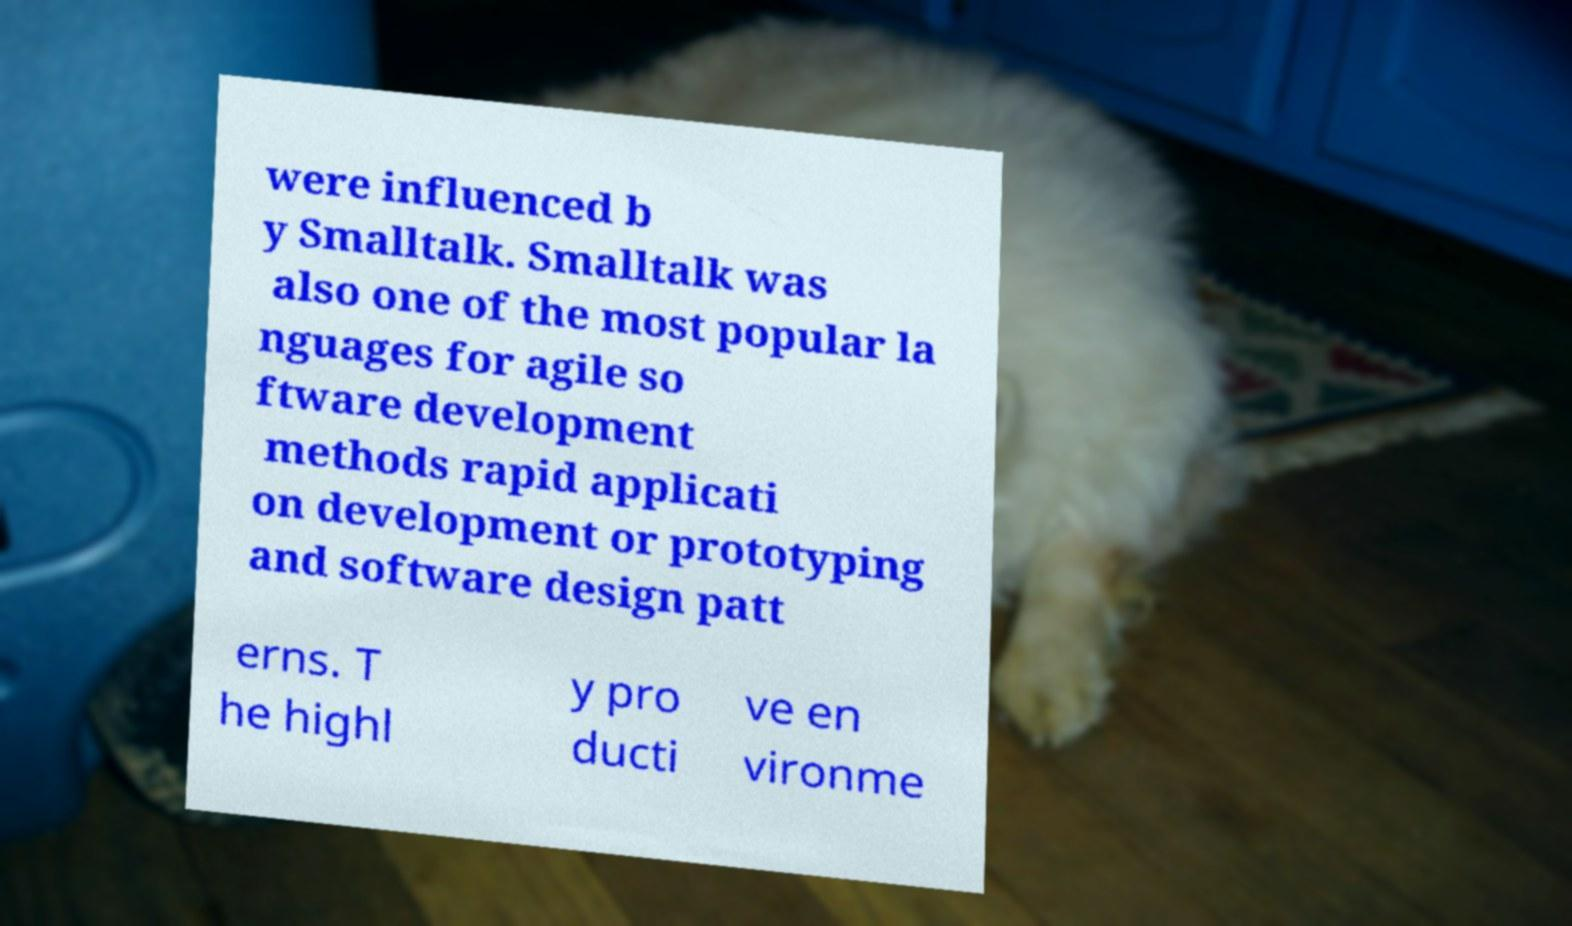For documentation purposes, I need the text within this image transcribed. Could you provide that? were influenced b y Smalltalk. Smalltalk was also one of the most popular la nguages for agile so ftware development methods rapid applicati on development or prototyping and software design patt erns. T he highl y pro ducti ve en vironme 